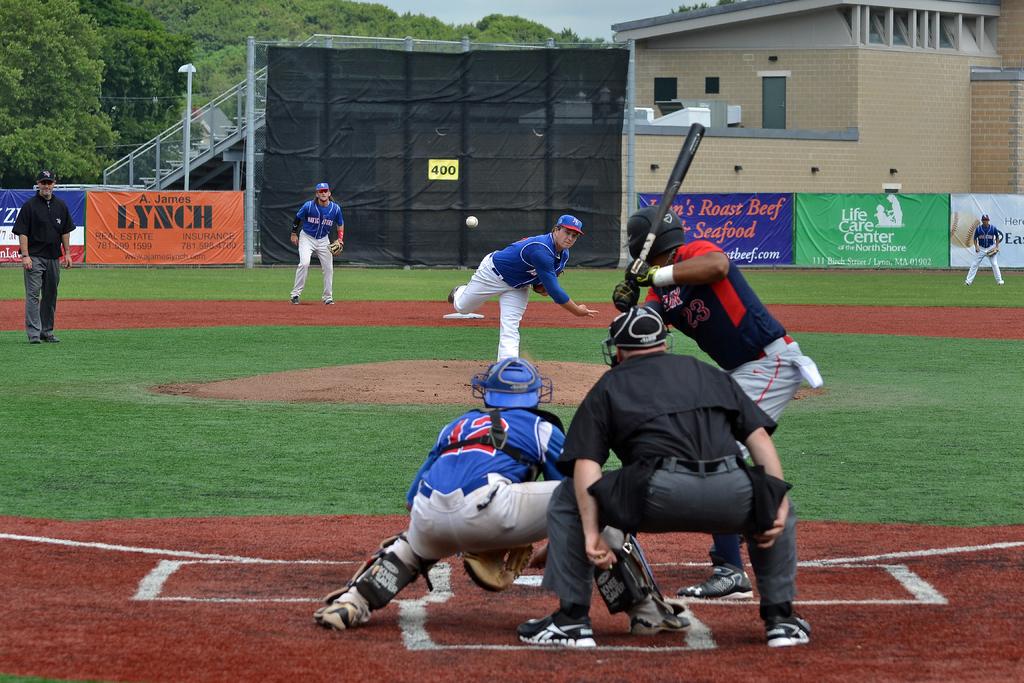What food is being offered by the company that has a banner?
Your response must be concise. Roast beef & seafood. According to the banner what type of center?
Provide a short and direct response. Life care. 